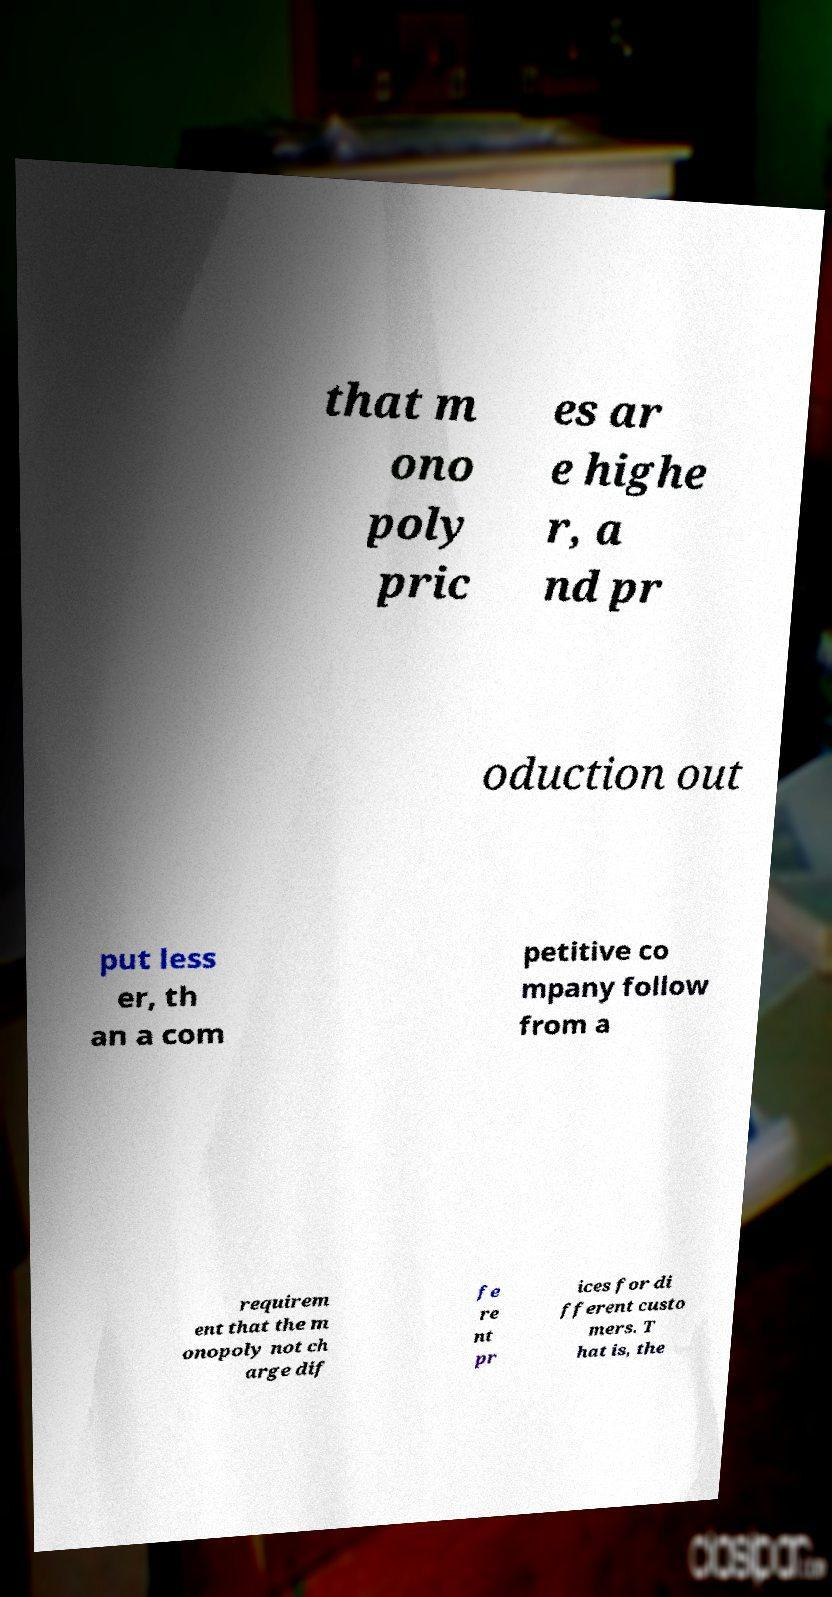Could you assist in decoding the text presented in this image and type it out clearly? that m ono poly pric es ar e highe r, a nd pr oduction out put less er, th an a com petitive co mpany follow from a requirem ent that the m onopoly not ch arge dif fe re nt pr ices for di fferent custo mers. T hat is, the 